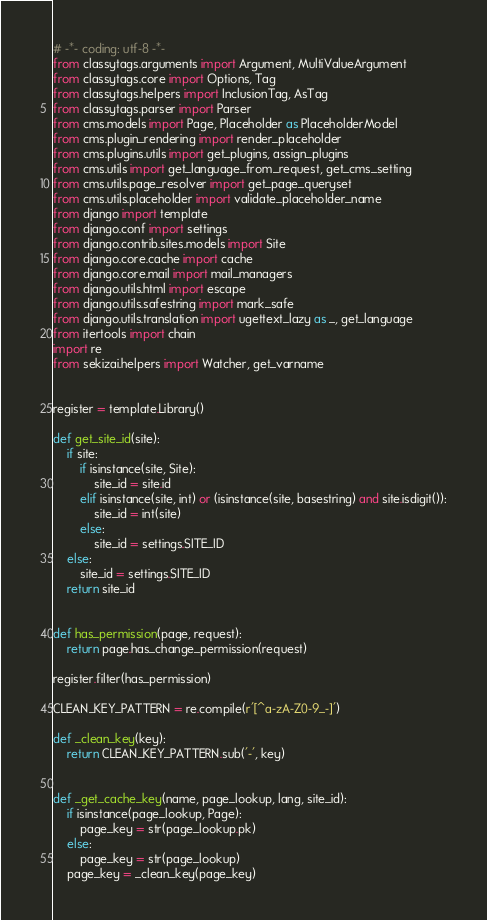<code> <loc_0><loc_0><loc_500><loc_500><_Python_># -*- coding: utf-8 -*-
from classytags.arguments import Argument, MultiValueArgument
from classytags.core import Options, Tag
from classytags.helpers import InclusionTag, AsTag
from classytags.parser import Parser
from cms.models import Page, Placeholder as PlaceholderModel
from cms.plugin_rendering import render_placeholder
from cms.plugins.utils import get_plugins, assign_plugins
from cms.utils import get_language_from_request, get_cms_setting
from cms.utils.page_resolver import get_page_queryset
from cms.utils.placeholder import validate_placeholder_name
from django import template
from django.conf import settings
from django.contrib.sites.models import Site
from django.core.cache import cache
from django.core.mail import mail_managers
from django.utils.html import escape
from django.utils.safestring import mark_safe
from django.utils.translation import ugettext_lazy as _, get_language
from itertools import chain
import re
from sekizai.helpers import Watcher, get_varname


register = template.Library()

def get_site_id(site):
    if site:
        if isinstance(site, Site):
            site_id = site.id
        elif isinstance(site, int) or (isinstance(site, basestring) and site.isdigit()):
            site_id = int(site)
        else:
            site_id = settings.SITE_ID
    else:
        site_id = settings.SITE_ID
    return site_id


def has_permission(page, request):
    return page.has_change_permission(request)

register.filter(has_permission)

CLEAN_KEY_PATTERN = re.compile(r'[^a-zA-Z0-9_-]')

def _clean_key(key):
    return CLEAN_KEY_PATTERN.sub('-', key)


def _get_cache_key(name, page_lookup, lang, site_id):
    if isinstance(page_lookup, Page):
        page_key = str(page_lookup.pk)
    else:
        page_key = str(page_lookup)
    page_key = _clean_key(page_key)</code> 